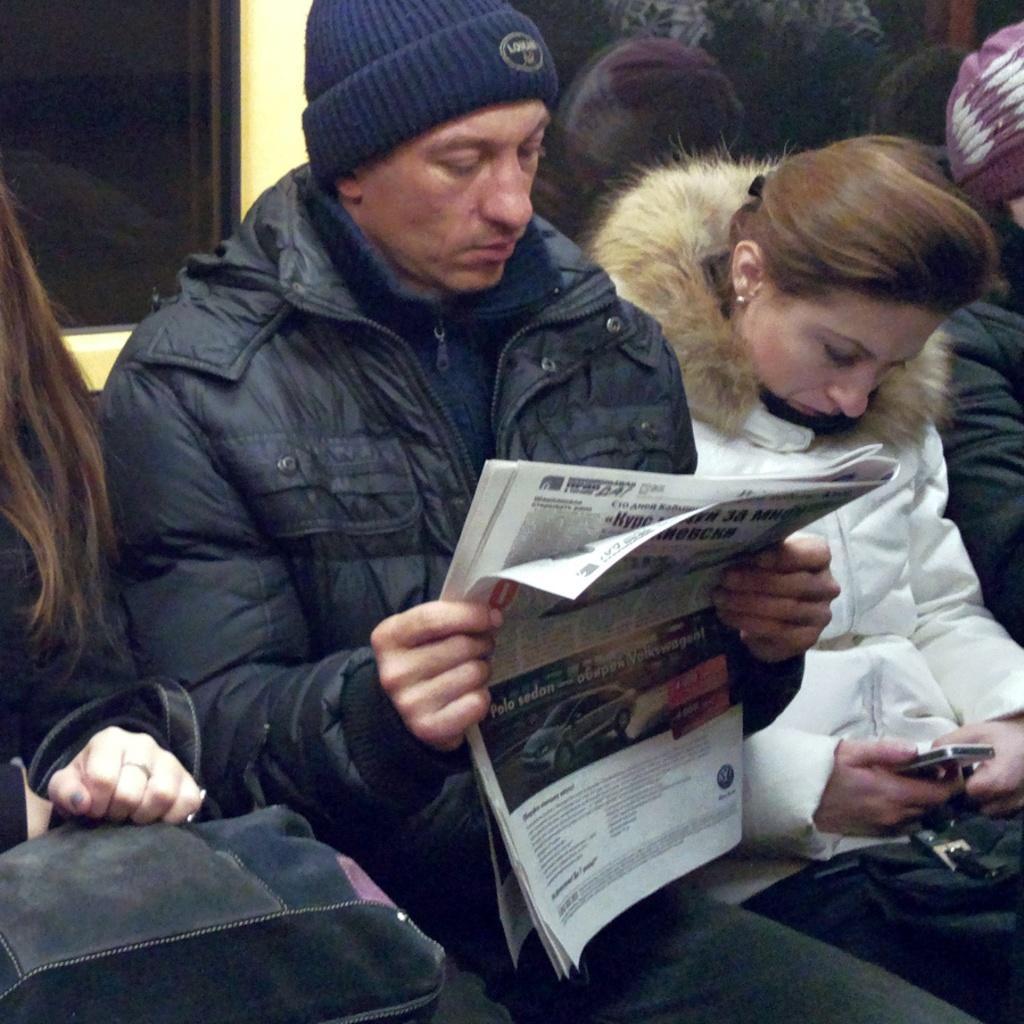Describe this image in one or two sentences. This picture shows few people seated and we see they wore jackets and we see a woman holding a mobile in her hand and a man holding a newspaper and reading it and we see a hand bag and a cap on his head. 